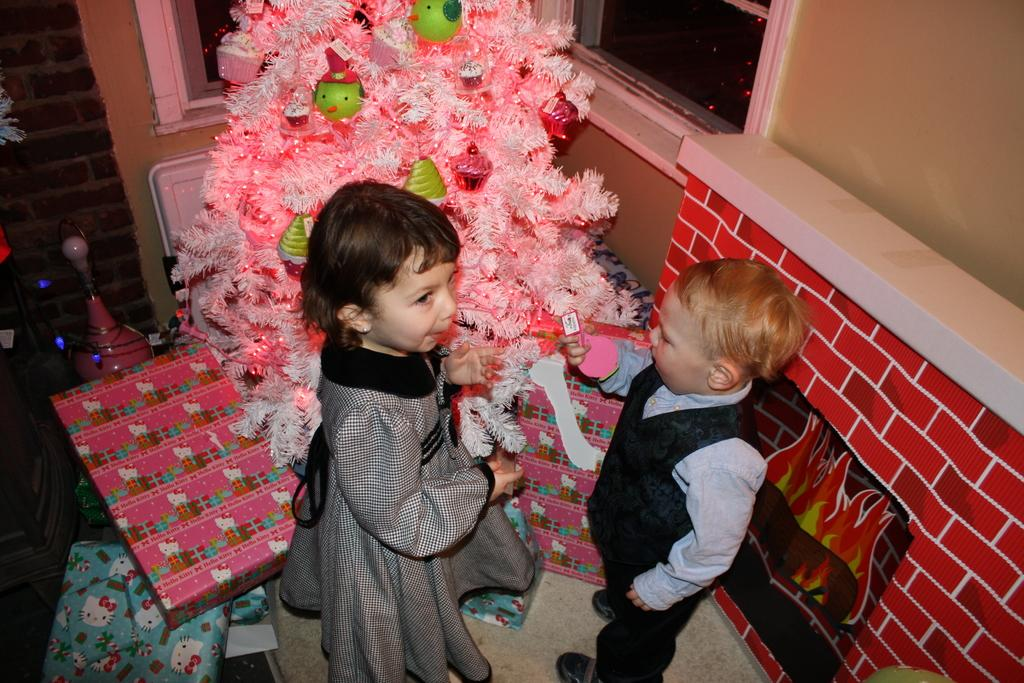How many kids are present in the image? There are two kids standing in the image. What are the kids holding in their hands? The kids are holding objects in the image. What decoration can be seen in the background of the image? There is a Christmas tree with lights in the image. What other items are associated with the holiday season in the image? There are gift boxes in the image. What architectural features can be seen in the image? There are windows and a wall in the image. What type of crime is being committed in the image? There is no crime being committed in the image; it features two kids standing with objects and a festive background. How does the wall in the image make the kids cry? The wall in the image does not make the kids cry; there is no indication of any emotional response from the kids in the image. 